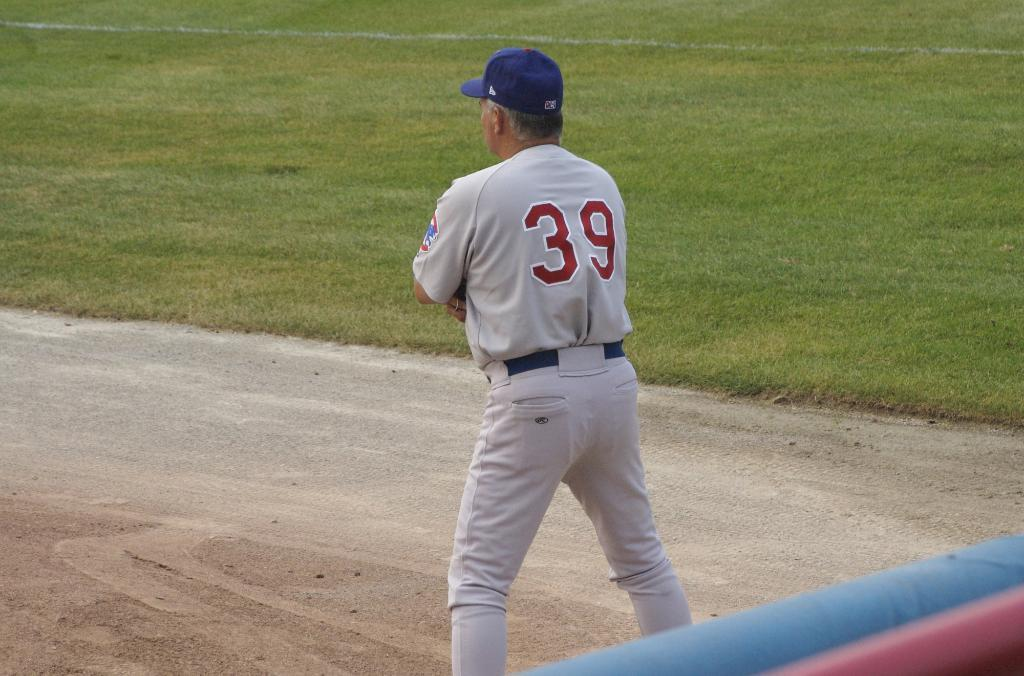What is the main subject of the image? There is a man standing in the image. What is the man wearing on his upper body? The man is wearing a shirt. What is the man wearing on his head? The man is wearing a cap. What is the man wearing on his lower body? The man is wearing pants. What type of natural environment is visible in the background of the image? There is grass in the background of the image. What type of development can be seen in the background of the image? There is no development visible in the background of the image; it features grass. What type of mist is present around the man in the image? There is no mist present in the image; it is a clear scene. 